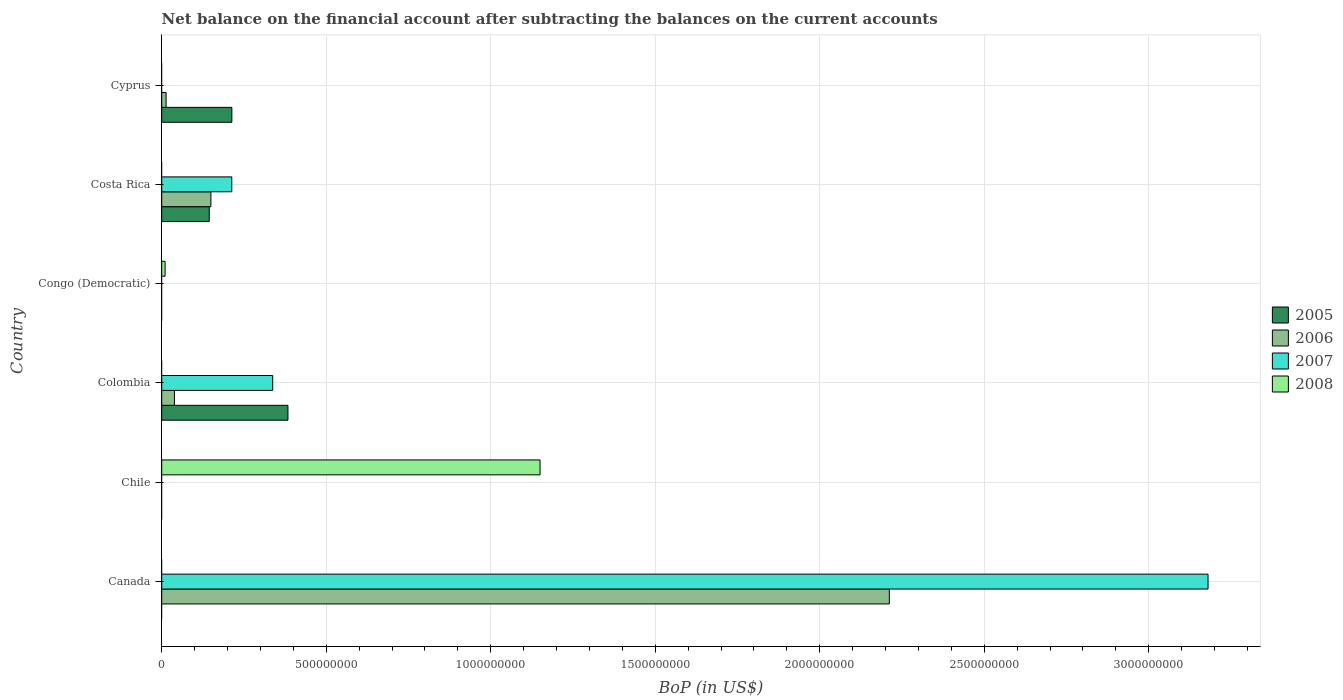Are the number of bars per tick equal to the number of legend labels?
Ensure brevity in your answer.  No. Are the number of bars on each tick of the Y-axis equal?
Your answer should be compact. No. How many bars are there on the 3rd tick from the top?
Keep it short and to the point. 1. What is the label of the 4th group of bars from the top?
Your answer should be very brief. Colombia. In how many cases, is the number of bars for a given country not equal to the number of legend labels?
Your answer should be compact. 6. What is the Balance of Payments in 2005 in Cyprus?
Offer a very short reply. 2.13e+08. Across all countries, what is the maximum Balance of Payments in 2007?
Your answer should be compact. 3.18e+09. Across all countries, what is the minimum Balance of Payments in 2005?
Give a very brief answer. 0. What is the total Balance of Payments in 2005 in the graph?
Provide a short and direct response. 7.41e+08. What is the difference between the Balance of Payments in 2007 in Canada and that in Costa Rica?
Your answer should be very brief. 2.97e+09. What is the difference between the Balance of Payments in 2005 in Cyprus and the Balance of Payments in 2008 in Canada?
Ensure brevity in your answer.  2.13e+08. What is the average Balance of Payments in 2006 per country?
Your answer should be compact. 4.02e+08. What is the difference between the Balance of Payments in 2006 and Balance of Payments in 2007 in Colombia?
Ensure brevity in your answer.  -2.99e+08. What is the ratio of the Balance of Payments in 2005 in Colombia to that in Costa Rica?
Offer a terse response. 2.66. Is the Balance of Payments in 2006 in Costa Rica less than that in Cyprus?
Offer a terse response. No. Is the difference between the Balance of Payments in 2006 in Canada and Costa Rica greater than the difference between the Balance of Payments in 2007 in Canada and Costa Rica?
Keep it short and to the point. No. What is the difference between the highest and the second highest Balance of Payments in 2005?
Offer a very short reply. 1.70e+08. What is the difference between the highest and the lowest Balance of Payments in 2007?
Make the answer very short. 3.18e+09. Is the sum of the Balance of Payments in 2006 in Colombia and Costa Rica greater than the maximum Balance of Payments in 2005 across all countries?
Your response must be concise. No. Is it the case that in every country, the sum of the Balance of Payments in 2006 and Balance of Payments in 2008 is greater than the Balance of Payments in 2005?
Ensure brevity in your answer.  No. Are all the bars in the graph horizontal?
Your answer should be very brief. Yes. How many countries are there in the graph?
Keep it short and to the point. 6. Does the graph contain any zero values?
Provide a succinct answer. Yes. Does the graph contain grids?
Your answer should be compact. Yes. How are the legend labels stacked?
Your response must be concise. Vertical. What is the title of the graph?
Make the answer very short. Net balance on the financial account after subtracting the balances on the current accounts. Does "2004" appear as one of the legend labels in the graph?
Ensure brevity in your answer.  No. What is the label or title of the X-axis?
Your answer should be compact. BoP (in US$). What is the BoP (in US$) of 2006 in Canada?
Your response must be concise. 2.21e+09. What is the BoP (in US$) in 2007 in Canada?
Ensure brevity in your answer.  3.18e+09. What is the BoP (in US$) in 2008 in Chile?
Your answer should be very brief. 1.15e+09. What is the BoP (in US$) in 2005 in Colombia?
Give a very brief answer. 3.84e+08. What is the BoP (in US$) in 2006 in Colombia?
Offer a very short reply. 3.87e+07. What is the BoP (in US$) in 2007 in Colombia?
Your response must be concise. 3.37e+08. What is the BoP (in US$) in 2005 in Congo (Democratic)?
Make the answer very short. 0. What is the BoP (in US$) of 2008 in Congo (Democratic)?
Give a very brief answer. 1.03e+07. What is the BoP (in US$) of 2005 in Costa Rica?
Your answer should be compact. 1.44e+08. What is the BoP (in US$) of 2006 in Costa Rica?
Your answer should be very brief. 1.50e+08. What is the BoP (in US$) of 2007 in Costa Rica?
Make the answer very short. 2.13e+08. What is the BoP (in US$) in 2005 in Cyprus?
Your answer should be very brief. 2.13e+08. What is the BoP (in US$) in 2006 in Cyprus?
Make the answer very short. 1.33e+07. What is the BoP (in US$) in 2008 in Cyprus?
Your answer should be compact. 0. Across all countries, what is the maximum BoP (in US$) in 2005?
Keep it short and to the point. 3.84e+08. Across all countries, what is the maximum BoP (in US$) in 2006?
Keep it short and to the point. 2.21e+09. Across all countries, what is the maximum BoP (in US$) in 2007?
Offer a terse response. 3.18e+09. Across all countries, what is the maximum BoP (in US$) of 2008?
Give a very brief answer. 1.15e+09. Across all countries, what is the minimum BoP (in US$) in 2005?
Provide a short and direct response. 0. Across all countries, what is the minimum BoP (in US$) in 2006?
Offer a very short reply. 0. Across all countries, what is the minimum BoP (in US$) in 2007?
Your answer should be compact. 0. What is the total BoP (in US$) of 2005 in the graph?
Ensure brevity in your answer.  7.41e+08. What is the total BoP (in US$) of 2006 in the graph?
Keep it short and to the point. 2.41e+09. What is the total BoP (in US$) in 2007 in the graph?
Provide a succinct answer. 3.73e+09. What is the total BoP (in US$) in 2008 in the graph?
Provide a short and direct response. 1.16e+09. What is the difference between the BoP (in US$) in 2006 in Canada and that in Colombia?
Ensure brevity in your answer.  2.17e+09. What is the difference between the BoP (in US$) of 2007 in Canada and that in Colombia?
Provide a succinct answer. 2.84e+09. What is the difference between the BoP (in US$) of 2006 in Canada and that in Costa Rica?
Your answer should be compact. 2.06e+09. What is the difference between the BoP (in US$) of 2007 in Canada and that in Costa Rica?
Give a very brief answer. 2.97e+09. What is the difference between the BoP (in US$) of 2006 in Canada and that in Cyprus?
Your answer should be compact. 2.20e+09. What is the difference between the BoP (in US$) of 2008 in Chile and that in Congo (Democratic)?
Keep it short and to the point. 1.14e+09. What is the difference between the BoP (in US$) of 2005 in Colombia and that in Costa Rica?
Give a very brief answer. 2.39e+08. What is the difference between the BoP (in US$) of 2006 in Colombia and that in Costa Rica?
Give a very brief answer. -1.11e+08. What is the difference between the BoP (in US$) in 2007 in Colombia and that in Costa Rica?
Offer a terse response. 1.24e+08. What is the difference between the BoP (in US$) of 2005 in Colombia and that in Cyprus?
Your answer should be very brief. 1.70e+08. What is the difference between the BoP (in US$) of 2006 in Colombia and that in Cyprus?
Provide a succinct answer. 2.53e+07. What is the difference between the BoP (in US$) of 2005 in Costa Rica and that in Cyprus?
Make the answer very short. -6.87e+07. What is the difference between the BoP (in US$) of 2006 in Costa Rica and that in Cyprus?
Keep it short and to the point. 1.36e+08. What is the difference between the BoP (in US$) in 2006 in Canada and the BoP (in US$) in 2008 in Chile?
Your answer should be compact. 1.06e+09. What is the difference between the BoP (in US$) in 2007 in Canada and the BoP (in US$) in 2008 in Chile?
Offer a terse response. 2.03e+09. What is the difference between the BoP (in US$) in 2006 in Canada and the BoP (in US$) in 2007 in Colombia?
Your answer should be compact. 1.87e+09. What is the difference between the BoP (in US$) of 2006 in Canada and the BoP (in US$) of 2008 in Congo (Democratic)?
Offer a terse response. 2.20e+09. What is the difference between the BoP (in US$) in 2007 in Canada and the BoP (in US$) in 2008 in Congo (Democratic)?
Offer a very short reply. 3.17e+09. What is the difference between the BoP (in US$) in 2006 in Canada and the BoP (in US$) in 2007 in Costa Rica?
Ensure brevity in your answer.  2.00e+09. What is the difference between the BoP (in US$) of 2005 in Colombia and the BoP (in US$) of 2008 in Congo (Democratic)?
Keep it short and to the point. 3.73e+08. What is the difference between the BoP (in US$) of 2006 in Colombia and the BoP (in US$) of 2008 in Congo (Democratic)?
Your answer should be compact. 2.84e+07. What is the difference between the BoP (in US$) in 2007 in Colombia and the BoP (in US$) in 2008 in Congo (Democratic)?
Provide a succinct answer. 3.27e+08. What is the difference between the BoP (in US$) in 2005 in Colombia and the BoP (in US$) in 2006 in Costa Rica?
Provide a succinct answer. 2.34e+08. What is the difference between the BoP (in US$) of 2005 in Colombia and the BoP (in US$) of 2007 in Costa Rica?
Your answer should be very brief. 1.71e+08. What is the difference between the BoP (in US$) of 2006 in Colombia and the BoP (in US$) of 2007 in Costa Rica?
Offer a terse response. -1.74e+08. What is the difference between the BoP (in US$) of 2005 in Colombia and the BoP (in US$) of 2006 in Cyprus?
Your answer should be compact. 3.70e+08. What is the difference between the BoP (in US$) of 2005 in Costa Rica and the BoP (in US$) of 2006 in Cyprus?
Keep it short and to the point. 1.31e+08. What is the average BoP (in US$) of 2005 per country?
Offer a very short reply. 1.24e+08. What is the average BoP (in US$) of 2006 per country?
Provide a succinct answer. 4.02e+08. What is the average BoP (in US$) in 2007 per country?
Keep it short and to the point. 6.22e+08. What is the average BoP (in US$) of 2008 per country?
Make the answer very short. 1.93e+08. What is the difference between the BoP (in US$) in 2006 and BoP (in US$) in 2007 in Canada?
Offer a terse response. -9.69e+08. What is the difference between the BoP (in US$) in 2005 and BoP (in US$) in 2006 in Colombia?
Your answer should be compact. 3.45e+08. What is the difference between the BoP (in US$) of 2005 and BoP (in US$) of 2007 in Colombia?
Keep it short and to the point. 4.63e+07. What is the difference between the BoP (in US$) in 2006 and BoP (in US$) in 2007 in Colombia?
Give a very brief answer. -2.99e+08. What is the difference between the BoP (in US$) in 2005 and BoP (in US$) in 2006 in Costa Rica?
Provide a short and direct response. -5.05e+06. What is the difference between the BoP (in US$) of 2005 and BoP (in US$) of 2007 in Costa Rica?
Offer a very short reply. -6.85e+07. What is the difference between the BoP (in US$) in 2006 and BoP (in US$) in 2007 in Costa Rica?
Offer a very short reply. -6.34e+07. What is the difference between the BoP (in US$) in 2005 and BoP (in US$) in 2006 in Cyprus?
Keep it short and to the point. 2.00e+08. What is the ratio of the BoP (in US$) of 2006 in Canada to that in Colombia?
Ensure brevity in your answer.  57.22. What is the ratio of the BoP (in US$) of 2007 in Canada to that in Colombia?
Make the answer very short. 9.43. What is the ratio of the BoP (in US$) of 2006 in Canada to that in Costa Rica?
Your answer should be very brief. 14.79. What is the ratio of the BoP (in US$) of 2007 in Canada to that in Costa Rica?
Provide a succinct answer. 14.93. What is the ratio of the BoP (in US$) in 2006 in Canada to that in Cyprus?
Offer a very short reply. 165.78. What is the ratio of the BoP (in US$) of 2008 in Chile to that in Congo (Democratic)?
Your answer should be very brief. 111.64. What is the ratio of the BoP (in US$) of 2005 in Colombia to that in Costa Rica?
Provide a short and direct response. 2.66. What is the ratio of the BoP (in US$) of 2006 in Colombia to that in Costa Rica?
Provide a short and direct response. 0.26. What is the ratio of the BoP (in US$) in 2007 in Colombia to that in Costa Rica?
Your answer should be very brief. 1.58. What is the ratio of the BoP (in US$) in 2005 in Colombia to that in Cyprus?
Your response must be concise. 1.8. What is the ratio of the BoP (in US$) in 2006 in Colombia to that in Cyprus?
Keep it short and to the point. 2.9. What is the ratio of the BoP (in US$) of 2005 in Costa Rica to that in Cyprus?
Your answer should be compact. 0.68. What is the ratio of the BoP (in US$) in 2006 in Costa Rica to that in Cyprus?
Your answer should be compact. 11.21. What is the difference between the highest and the second highest BoP (in US$) in 2005?
Offer a terse response. 1.70e+08. What is the difference between the highest and the second highest BoP (in US$) in 2006?
Make the answer very short. 2.06e+09. What is the difference between the highest and the second highest BoP (in US$) of 2007?
Give a very brief answer. 2.84e+09. What is the difference between the highest and the lowest BoP (in US$) in 2005?
Keep it short and to the point. 3.84e+08. What is the difference between the highest and the lowest BoP (in US$) of 2006?
Your answer should be very brief. 2.21e+09. What is the difference between the highest and the lowest BoP (in US$) in 2007?
Offer a terse response. 3.18e+09. What is the difference between the highest and the lowest BoP (in US$) in 2008?
Ensure brevity in your answer.  1.15e+09. 